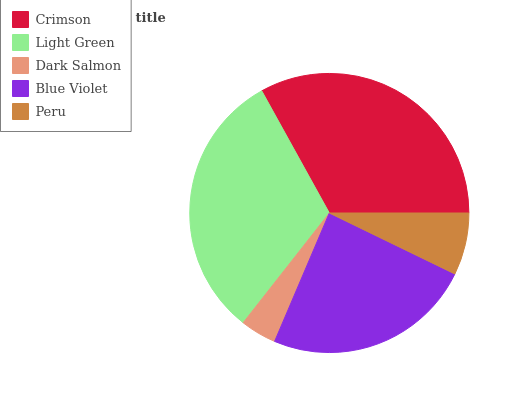Is Dark Salmon the minimum?
Answer yes or no. Yes. Is Crimson the maximum?
Answer yes or no. Yes. Is Light Green the minimum?
Answer yes or no. No. Is Light Green the maximum?
Answer yes or no. No. Is Crimson greater than Light Green?
Answer yes or no. Yes. Is Light Green less than Crimson?
Answer yes or no. Yes. Is Light Green greater than Crimson?
Answer yes or no. No. Is Crimson less than Light Green?
Answer yes or no. No. Is Blue Violet the high median?
Answer yes or no. Yes. Is Blue Violet the low median?
Answer yes or no. Yes. Is Dark Salmon the high median?
Answer yes or no. No. Is Peru the low median?
Answer yes or no. No. 